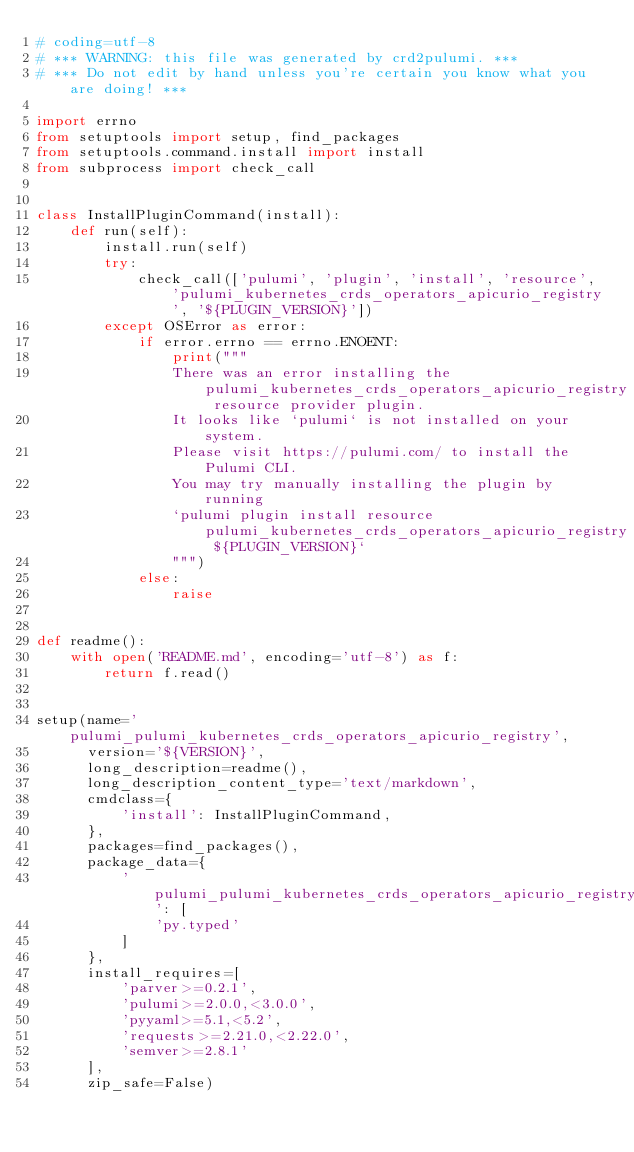<code> <loc_0><loc_0><loc_500><loc_500><_Python_># coding=utf-8
# *** WARNING: this file was generated by crd2pulumi. ***
# *** Do not edit by hand unless you're certain you know what you are doing! ***

import errno
from setuptools import setup, find_packages
from setuptools.command.install import install
from subprocess import check_call


class InstallPluginCommand(install):
    def run(self):
        install.run(self)
        try:
            check_call(['pulumi', 'plugin', 'install', 'resource', 'pulumi_kubernetes_crds_operators_apicurio_registry', '${PLUGIN_VERSION}'])
        except OSError as error:
            if error.errno == errno.ENOENT:
                print("""
                There was an error installing the pulumi_kubernetes_crds_operators_apicurio_registry resource provider plugin.
                It looks like `pulumi` is not installed on your system.
                Please visit https://pulumi.com/ to install the Pulumi CLI.
                You may try manually installing the plugin by running
                `pulumi plugin install resource pulumi_kubernetes_crds_operators_apicurio_registry ${PLUGIN_VERSION}`
                """)
            else:
                raise


def readme():
    with open('README.md', encoding='utf-8') as f:
        return f.read()


setup(name='pulumi_pulumi_kubernetes_crds_operators_apicurio_registry',
      version='${VERSION}',
      long_description=readme(),
      long_description_content_type='text/markdown',
      cmdclass={
          'install': InstallPluginCommand,
      },
      packages=find_packages(),
      package_data={
          'pulumi_pulumi_kubernetes_crds_operators_apicurio_registry': [
              'py.typed'
          ]
      },
      install_requires=[
          'parver>=0.2.1',
          'pulumi>=2.0.0,<3.0.0',
          'pyyaml>=5.1,<5.2',
          'requests>=2.21.0,<2.22.0',
          'semver>=2.8.1'
      ],
      zip_safe=False)
</code> 